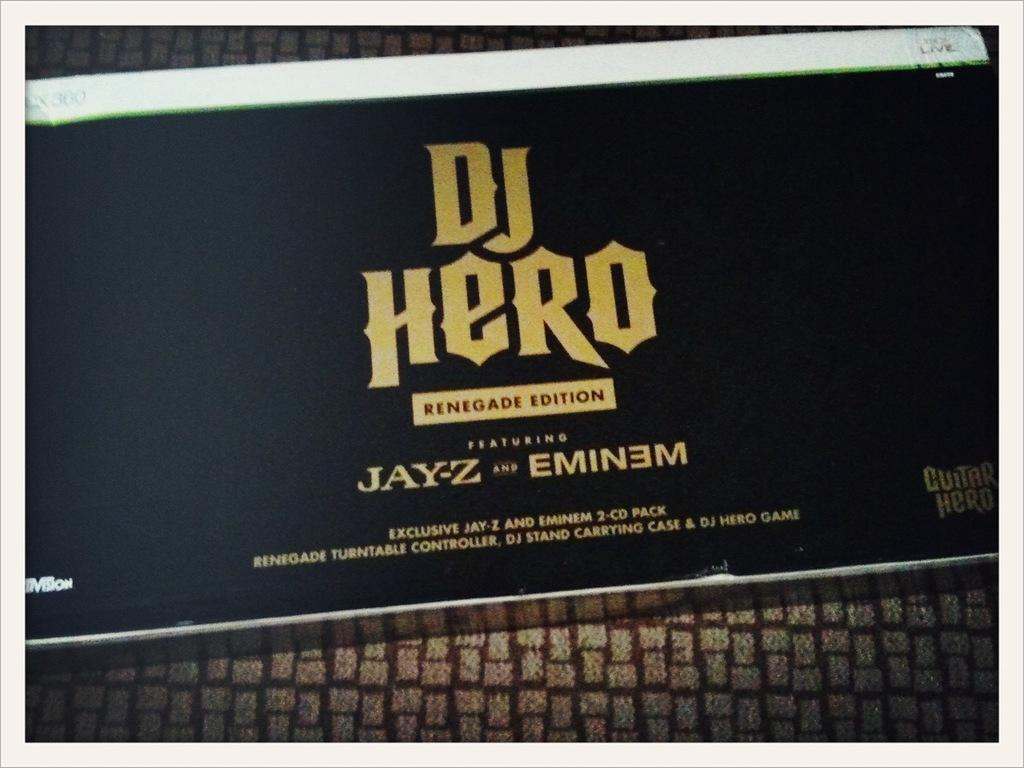<image>
Share a concise interpretation of the image provided. A sign that says DJ Hero tells us that this is the renegade edition. 